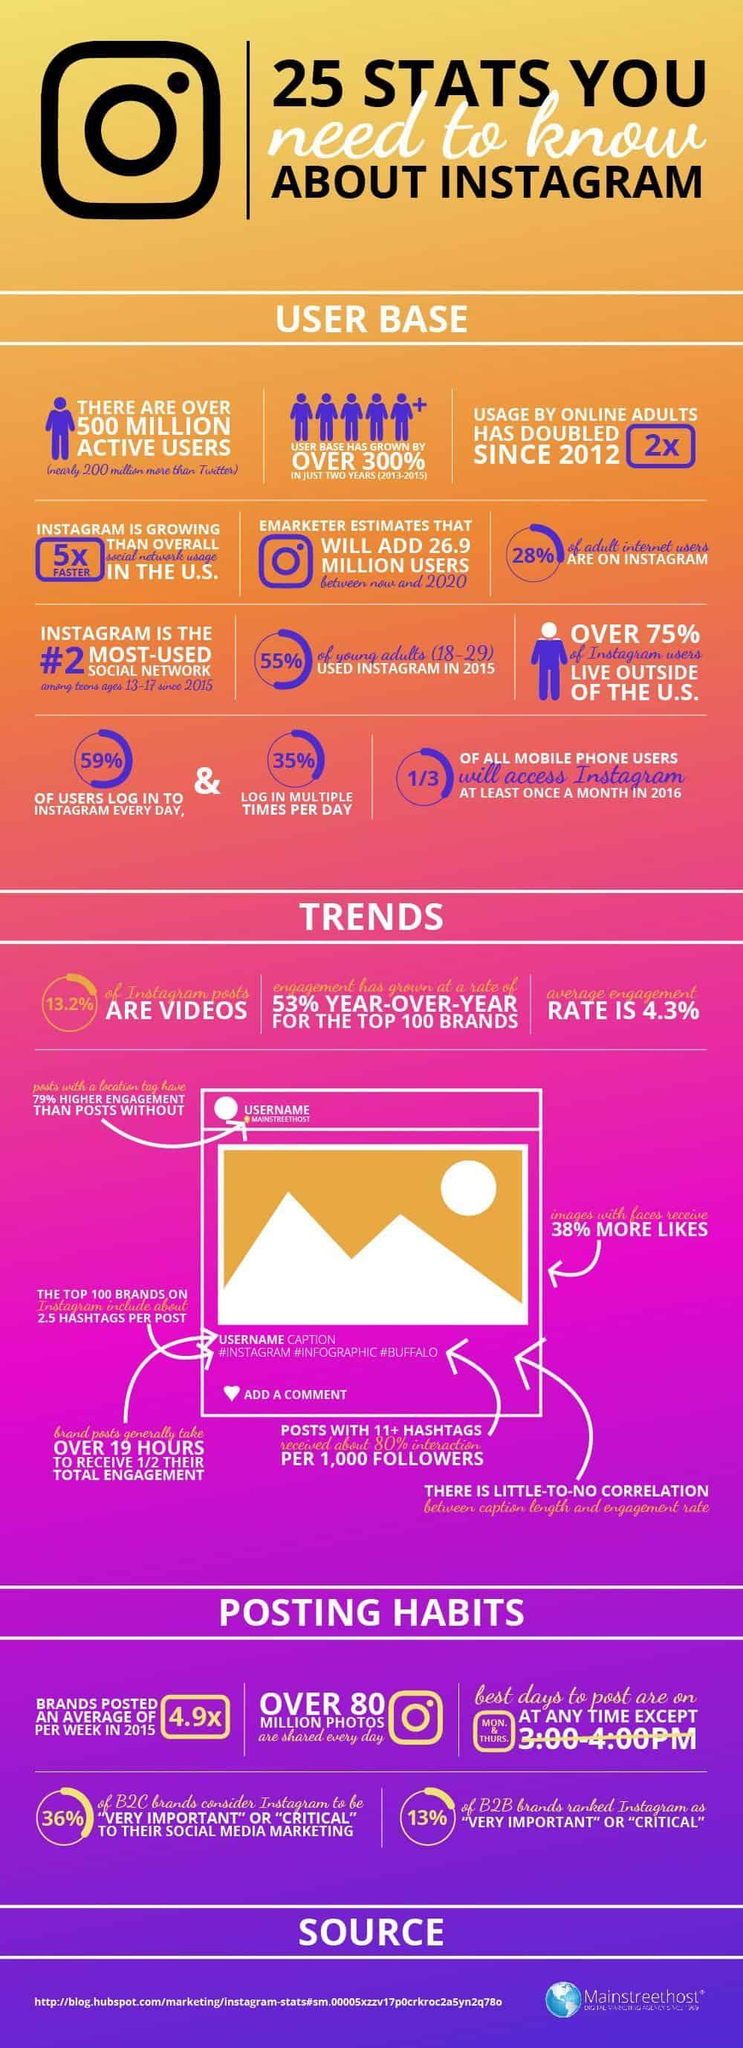What is the inverse percentage of likes getting for a Instagram photos with faces?
Answer the question with a short phrase. 62 What percentage of Instagram users are living inside U.S? 25% How many photos are getting shared through Instagram in a day? over 80 million photos How many people checks Instagram different times a day? 35% How many people uses Instagram on daily basis? 59% How much is the growth of Instagram users in just two years 2013-2015? over 300% Which is the popular social media platform after Facebook- Whats app, Instagram, Twitter, YouTube? Instagram What is the average engagement score of Instagram? 4.3% What percentage of Grown up Internet users are not in the Instagram? 72 